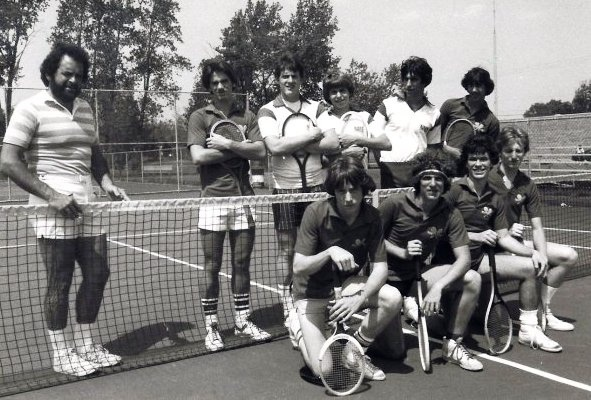Describe the objects in this image and their specific colors. I can see people in black, gray, lightgray, and darkgray tones, people in black, gray, lightgray, and darkgray tones, people in black, gray, lightgray, and darkgray tones, people in black, gray, lightgray, and darkgray tones, and people in black, white, gray, and darkgray tones in this image. 